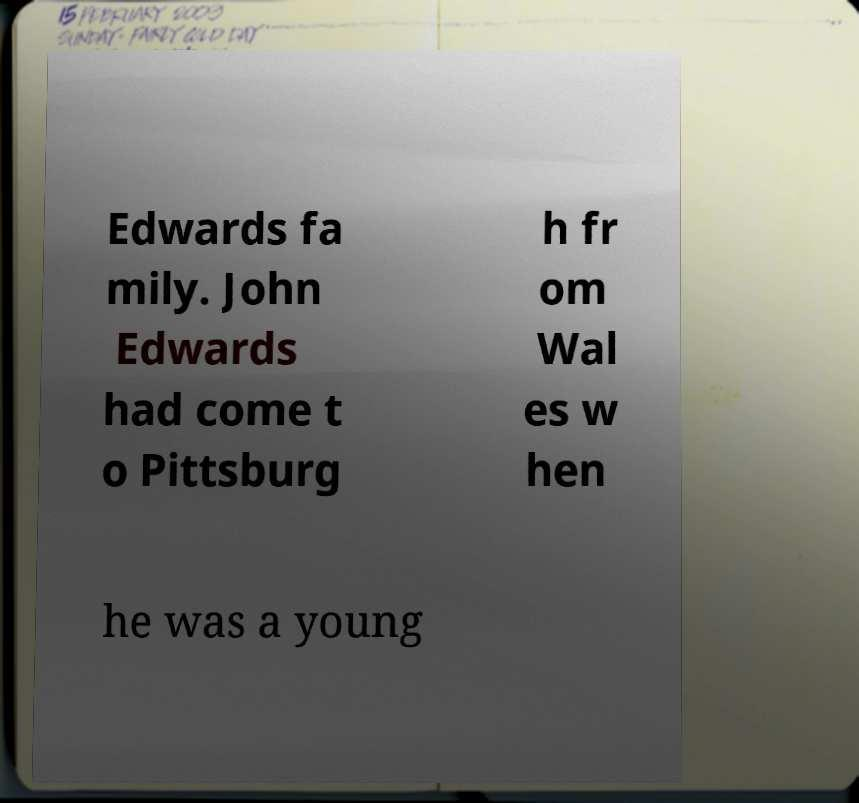There's text embedded in this image that I need extracted. Can you transcribe it verbatim? Edwards fa mily. John Edwards had come t o Pittsburg h fr om Wal es w hen he was a young 